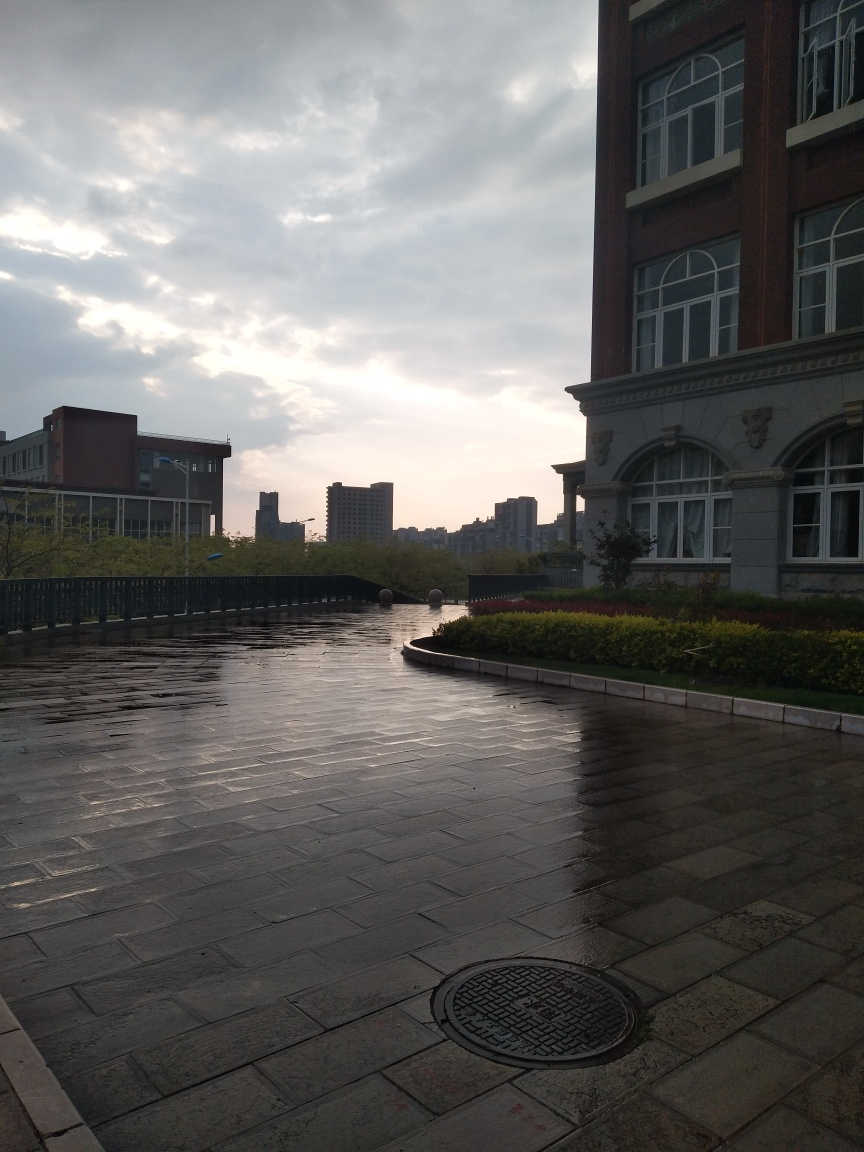What is the subject of the image? The image depicts an urban scene just after a rain shower, with wet paving stones reflecting the cloudy sky and the remaining sunlight. There are buildings in the background and a lush green hedge to the right. The atmosphere is serene and somewhat dramatic due to the play of light and shadows. 